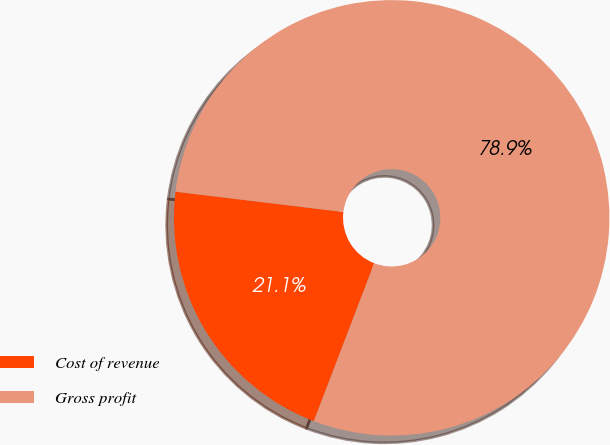Convert chart. <chart><loc_0><loc_0><loc_500><loc_500><pie_chart><fcel>Cost of revenue<fcel>Gross profit<nl><fcel>21.1%<fcel>78.9%<nl></chart> 